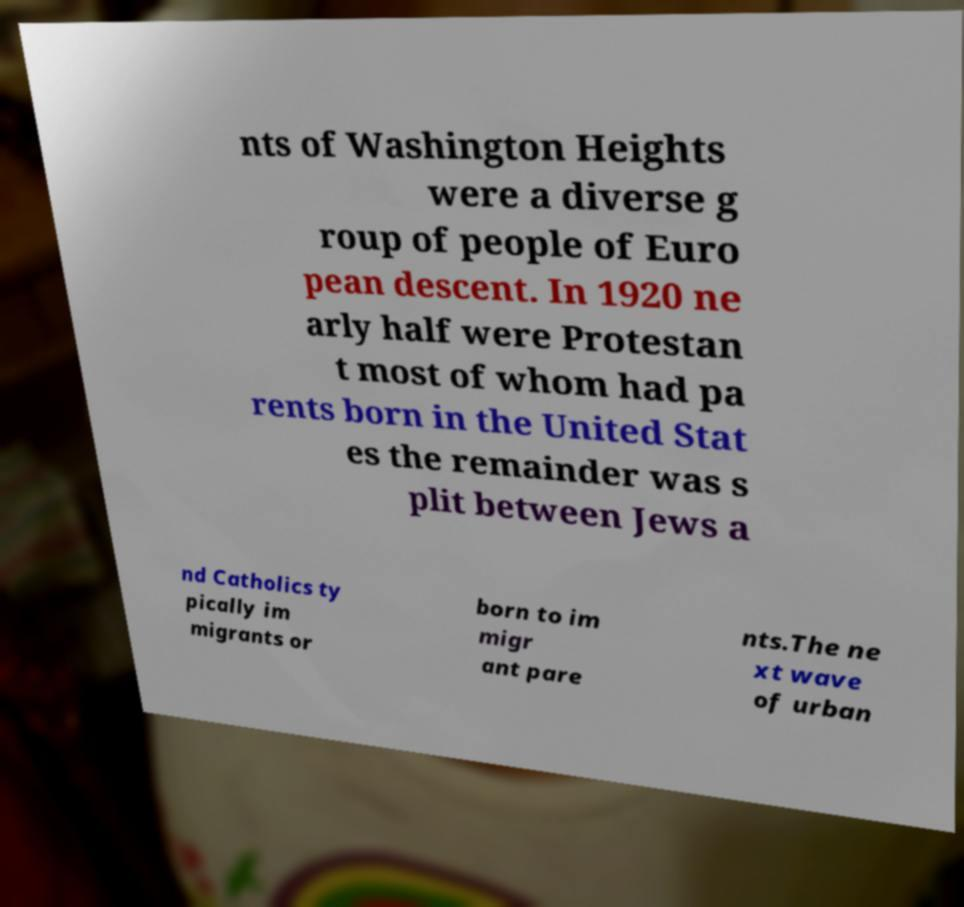I need the written content from this picture converted into text. Can you do that? nts of Washington Heights were a diverse g roup of people of Euro pean descent. In 1920 ne arly half were Protestan t most of whom had pa rents born in the United Stat es the remainder was s plit between Jews a nd Catholics ty pically im migrants or born to im migr ant pare nts.The ne xt wave of urban 